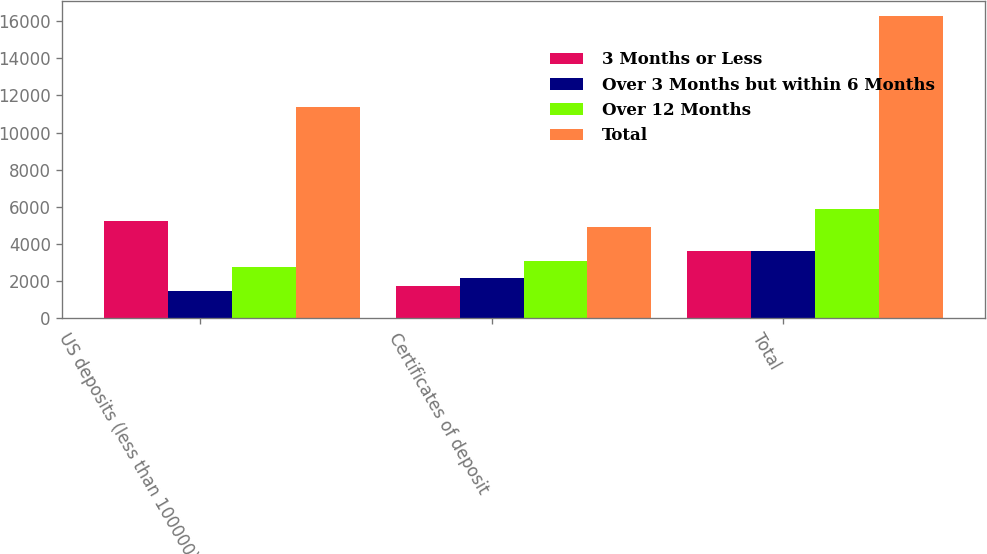Convert chart. <chart><loc_0><loc_0><loc_500><loc_500><stacked_bar_chart><ecel><fcel>US deposits (less than 100000)<fcel>Certificates of deposit<fcel>Total<nl><fcel>3 Months or Less<fcel>5234<fcel>1747<fcel>3629<nl><fcel>Over 3 Months but within 6 Months<fcel>1447<fcel>2182<fcel>3629<nl><fcel>Over 12 Months<fcel>2779<fcel>3108<fcel>5887<nl><fcel>Total<fcel>11362<fcel>4898<fcel>16260<nl></chart> 